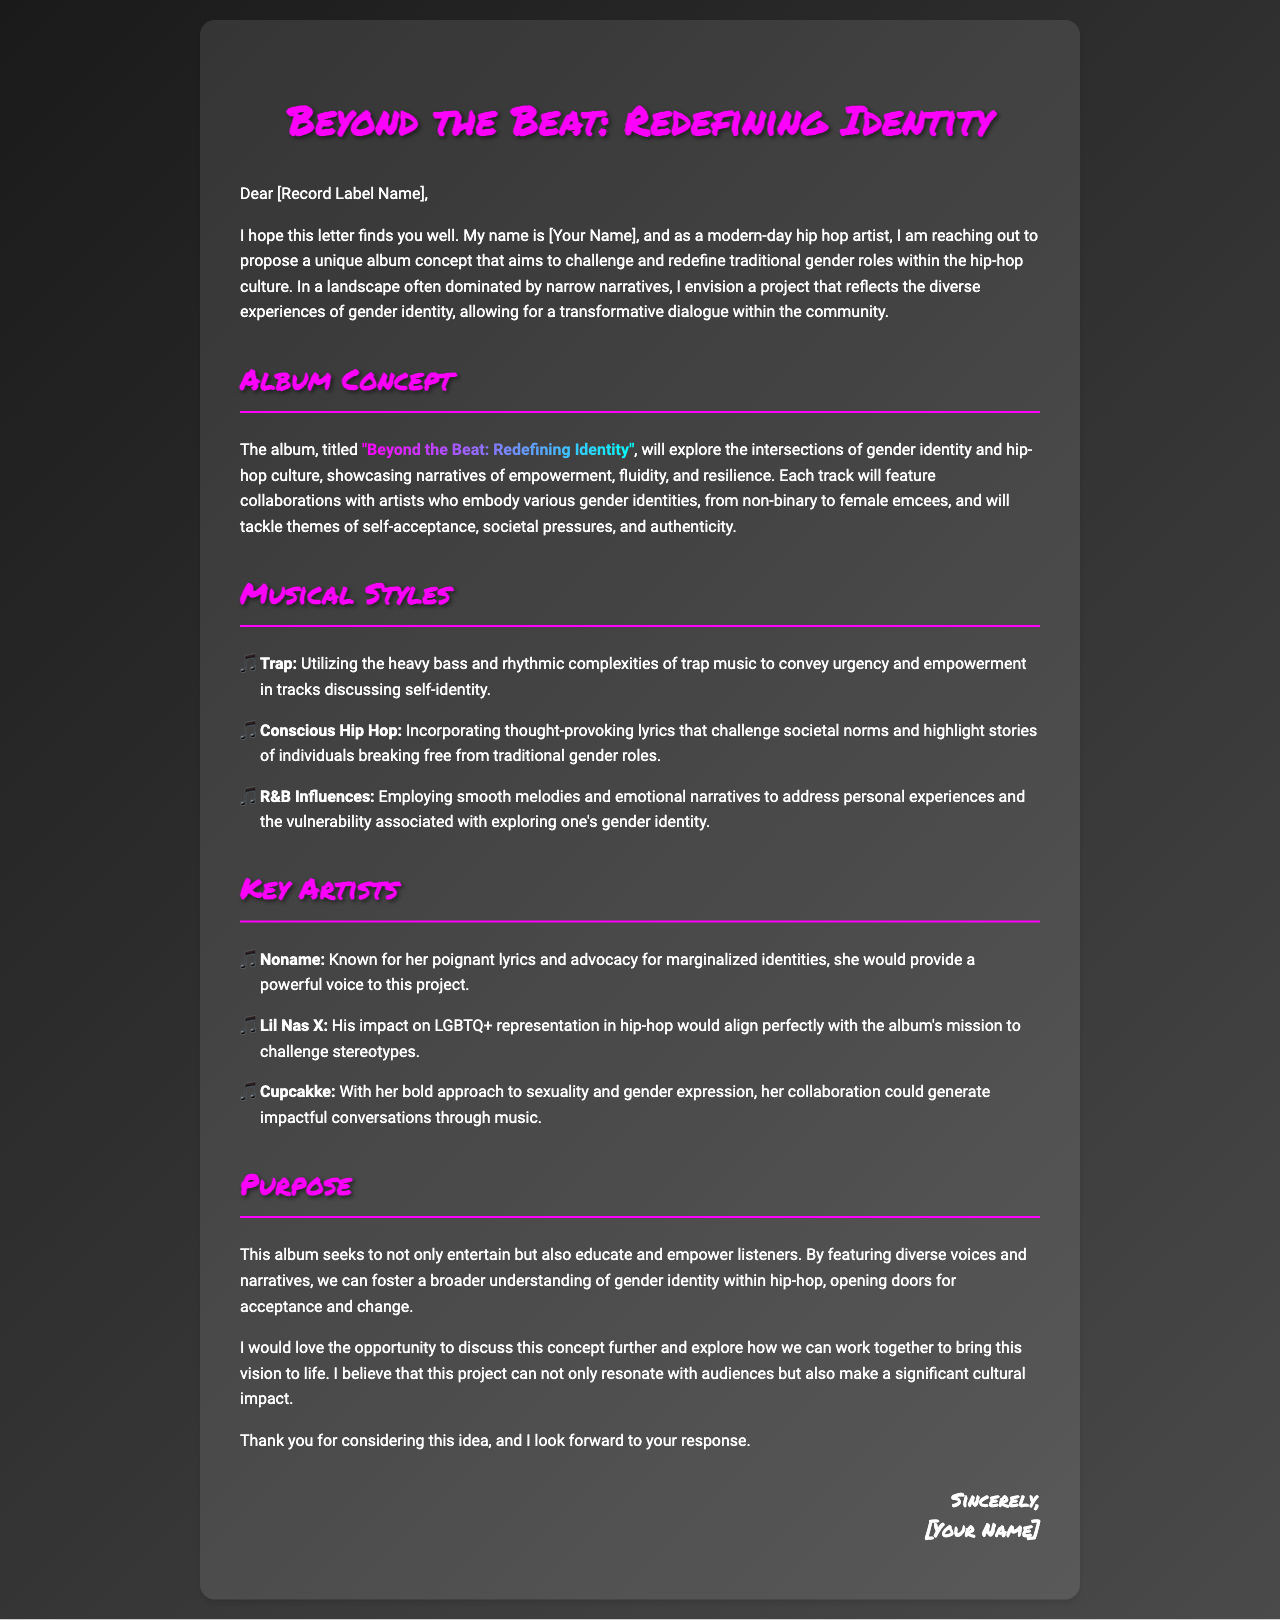What is the title of the album? The title of the album is mentioned in the document as "Beyond the Beat: Redefining Identity."
Answer: "Beyond the Beat: Redefining Identity" Who is the artist proposing the album? The artist proposing the album is indicated as [Your Name] in the document.
Answer: [Your Name] Which musical style uses heavy bass and rhythmic complexities? The document states that Trap utilizes heavy bass and rhythmic complexities.
Answer: Trap Name one key artist mentioned in the proposal. The document lists Noname as one of the key artists.
Answer: Noname What is the primary purpose of the album? The document outlines the purpose as educating and empowering listeners regarding gender identity.
Answer: Educate and empower How many musical styles are mentioned in the document? The document mentions three musical styles: Trap, Conscious Hip Hop, and R&B Influences.
Answer: Three Which section outlines the album's themes? The Album Concept section outlines the themes of empowerment, fluidity, and resilience.
Answer: Album Concept What is the intended impact of this album on hip-hop culture? The intended impact includes fostering a broader understanding of gender identity within hip-hop.
Answer: Broader understanding Who is credited with challenging stereotypes in hip-hop according to the proposal? Lil Nas X is credited with challenging stereotypes in hip-hop.
Answer: Lil Nas X 